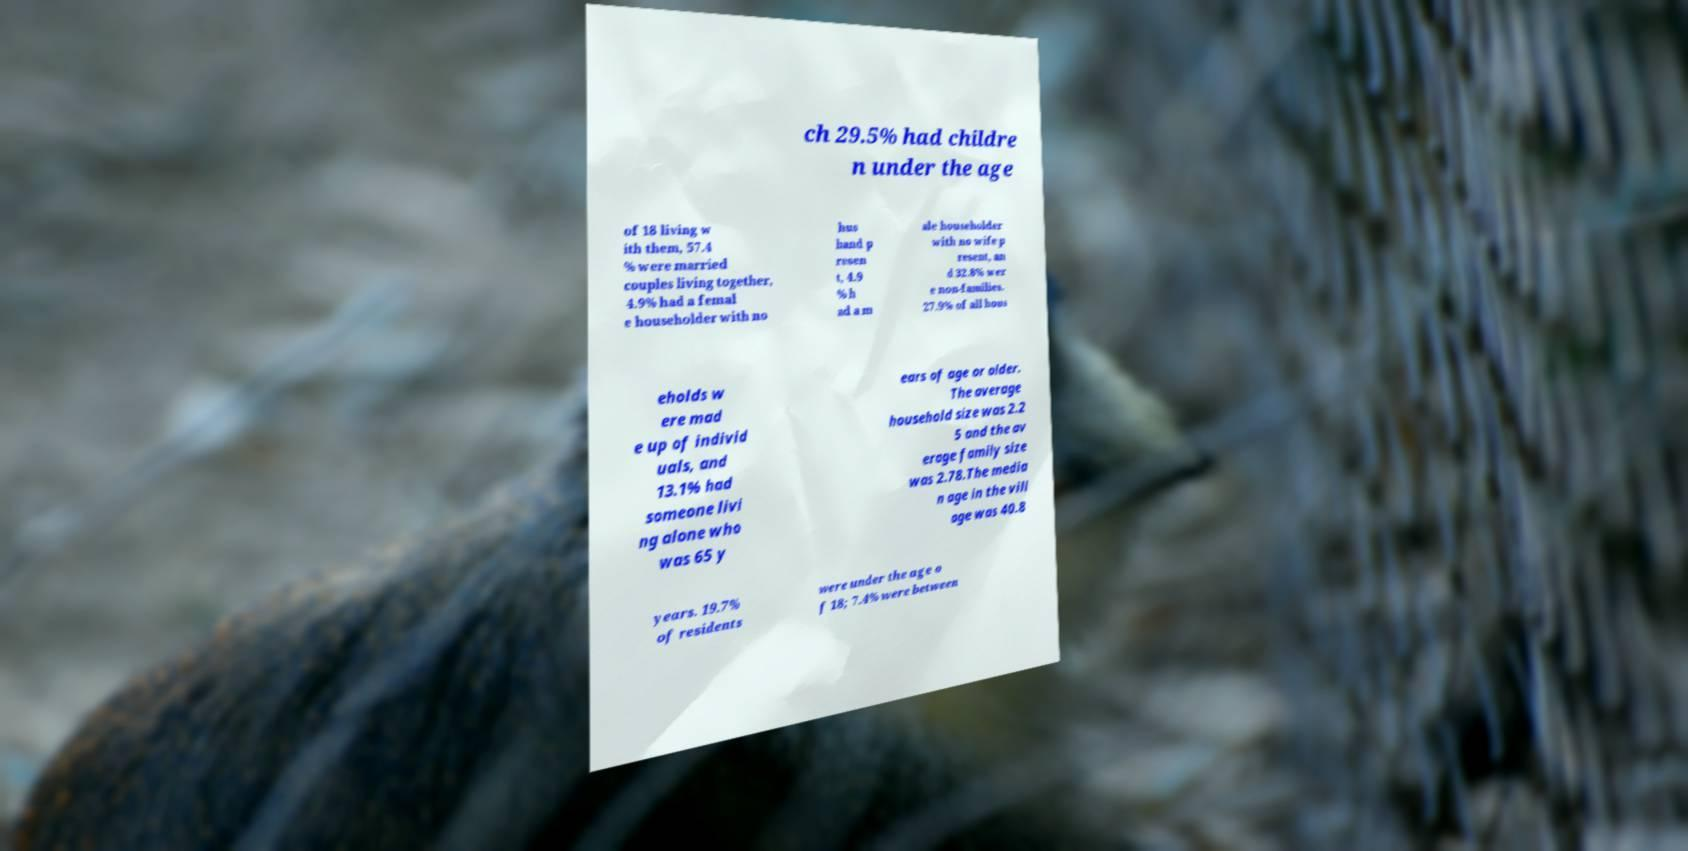Please identify and transcribe the text found in this image. ch 29.5% had childre n under the age of 18 living w ith them, 57.4 % were married couples living together, 4.9% had a femal e householder with no hus band p resen t, 4.9 % h ad a m ale householder with no wife p resent, an d 32.8% wer e non-families. 27.9% of all hous eholds w ere mad e up of individ uals, and 13.1% had someone livi ng alone who was 65 y ears of age or older. The average household size was 2.2 5 and the av erage family size was 2.78.The media n age in the vill age was 40.8 years. 19.7% of residents were under the age o f 18; 7.4% were between 